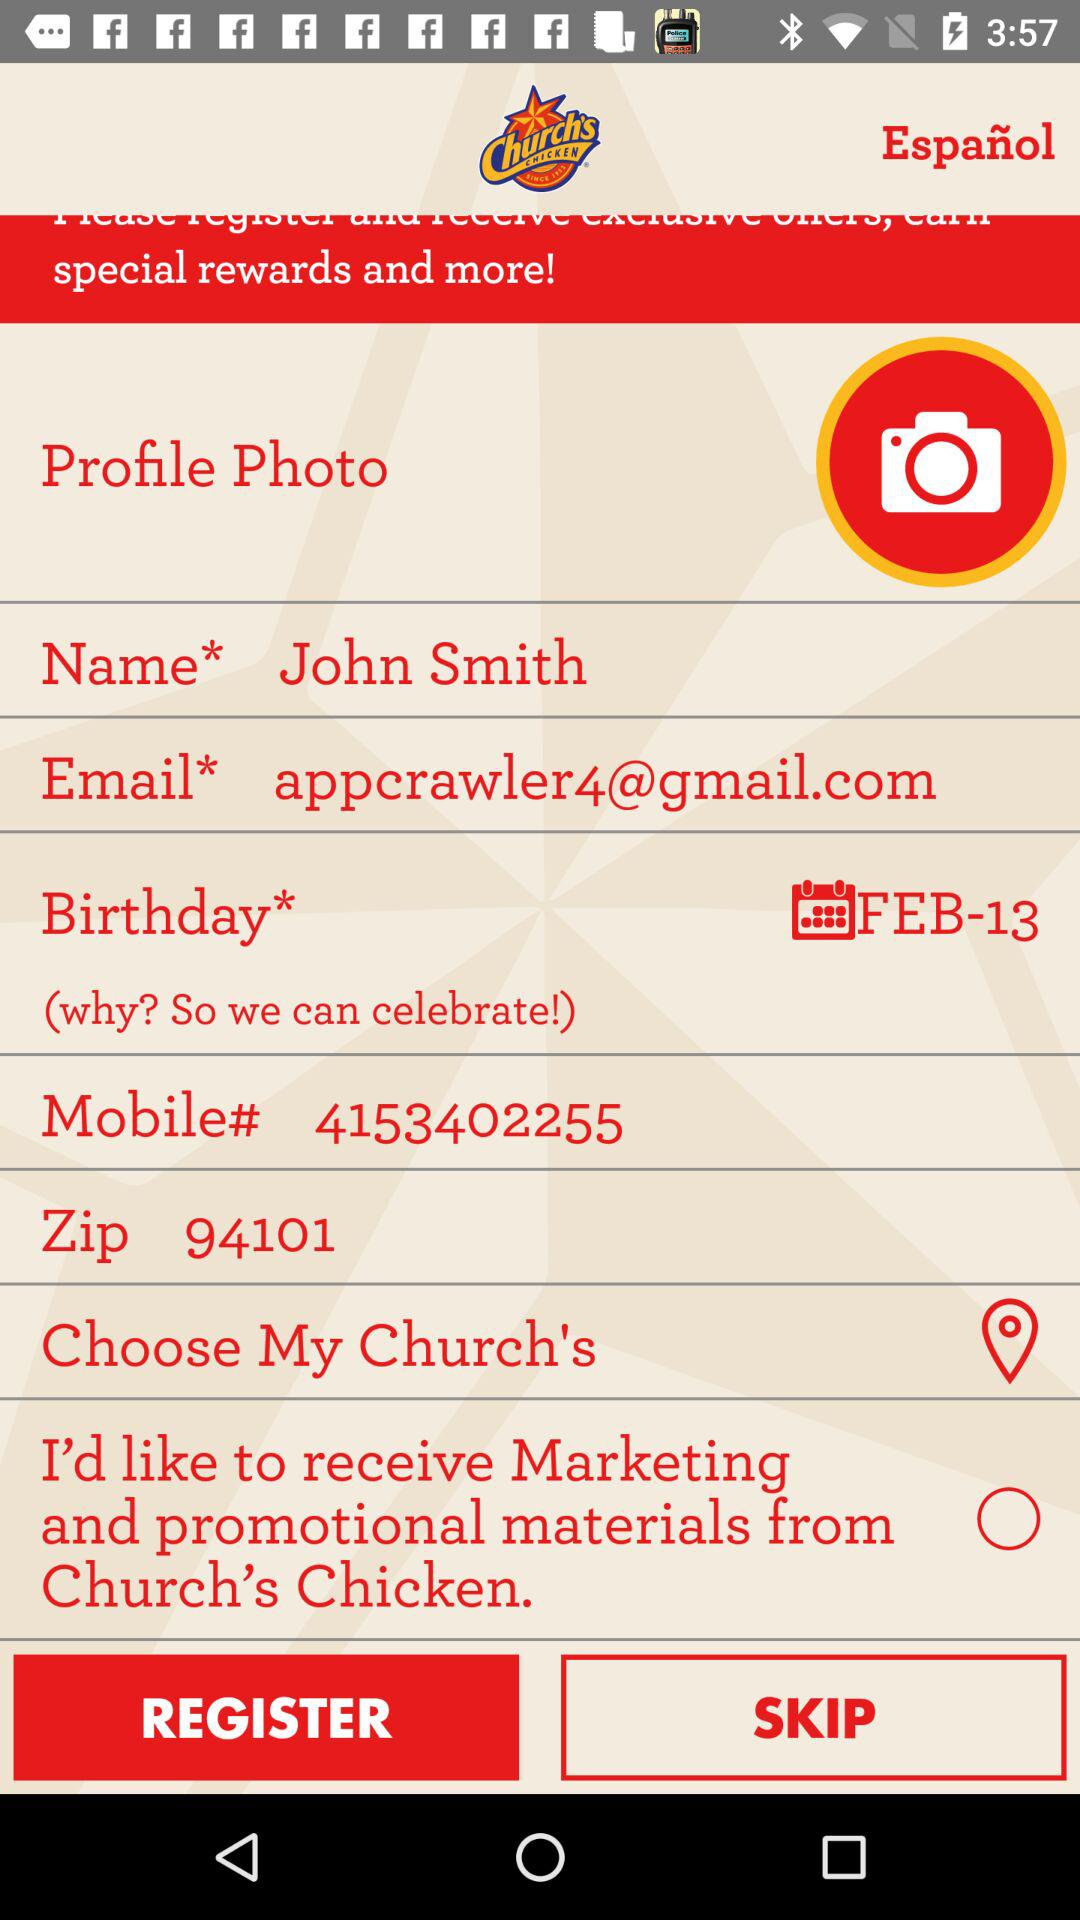What is the phone number? The phone number is 4153402255. 